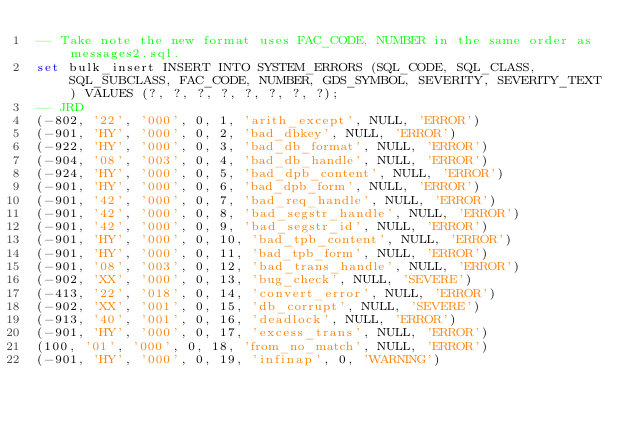<code> <loc_0><loc_0><loc_500><loc_500><_SQL_>-- Take note the new format uses FAC_CODE, NUMBER in the same order as messages2.sql.
set bulk_insert INSERT INTO SYSTEM_ERRORS (SQL_CODE, SQL_CLASS, SQL_SUBCLASS, FAC_CODE, NUMBER, GDS_SYMBOL, SEVERITY, SEVERITY_TEXT) VALUES (?, ?, ?, ?, ?, ?, ?, ?);
-- JRD
(-802, '22', '000', 0, 1, 'arith_except', NULL, 'ERROR')
(-901, 'HY', '000', 0, 2, 'bad_dbkey', NULL, 'ERROR')
(-922, 'HY', '000', 0, 3, 'bad_db_format', NULL, 'ERROR')
(-904, '08', '003', 0, 4, 'bad_db_handle', NULL, 'ERROR')
(-924, 'HY', '000', 0, 5, 'bad_dpb_content', NULL, 'ERROR')
(-901, 'HY', '000', 0, 6, 'bad_dpb_form', NULL, 'ERROR')
(-901, '42', '000', 0, 7, 'bad_req_handle', NULL, 'ERROR')
(-901, '42', '000', 0, 8, 'bad_segstr_handle', NULL, 'ERROR')
(-901, '42', '000', 0, 9, 'bad_segstr_id', NULL, 'ERROR')
(-901, 'HY', '000', 0, 10, 'bad_tpb_content', NULL, 'ERROR')
(-901, 'HY', '000', 0, 11, 'bad_tpb_form', NULL, 'ERROR')
(-901, '08', '003', 0, 12, 'bad_trans_handle', NULL, 'ERROR')
(-902, 'XX', '000', 0, 13, 'bug_check', NULL, 'SEVERE')
(-413, '22', '018', 0, 14, 'convert_error', NULL, 'ERROR')
(-902, 'XX', '001', 0, 15, 'db_corrupt', NULL, 'SEVERE')
(-913, '40', '001', 0, 16, 'deadlock', NULL, 'ERROR')
(-901, 'HY', '000', 0, 17, 'excess_trans', NULL, 'ERROR')
(100, '01', '000', 0, 18, 'from_no_match', NULL, 'ERROR')
(-901, 'HY', '000', 0, 19, 'infinap', 0, 'WARNING')</code> 